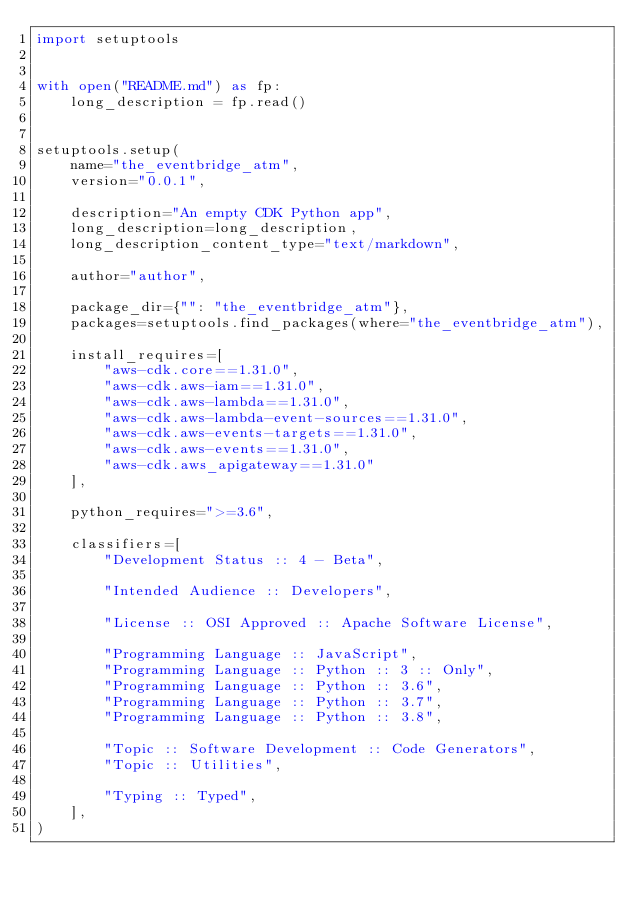Convert code to text. <code><loc_0><loc_0><loc_500><loc_500><_Python_>import setuptools


with open("README.md") as fp:
    long_description = fp.read()


setuptools.setup(
    name="the_eventbridge_atm",
    version="0.0.1",

    description="An empty CDK Python app",
    long_description=long_description,
    long_description_content_type="text/markdown",

    author="author",

    package_dir={"": "the_eventbridge_atm"},
    packages=setuptools.find_packages(where="the_eventbridge_atm"),

    install_requires=[
        "aws-cdk.core==1.31.0",
        "aws-cdk.aws-iam==1.31.0",
        "aws-cdk.aws-lambda==1.31.0",
        "aws-cdk.aws-lambda-event-sources==1.31.0",
        "aws-cdk.aws-events-targets==1.31.0",
        "aws-cdk.aws-events==1.31.0",
        "aws-cdk.aws_apigateway==1.31.0"
    ],

    python_requires=">=3.6",

    classifiers=[
        "Development Status :: 4 - Beta",

        "Intended Audience :: Developers",

        "License :: OSI Approved :: Apache Software License",

        "Programming Language :: JavaScript",
        "Programming Language :: Python :: 3 :: Only",
        "Programming Language :: Python :: 3.6",
        "Programming Language :: Python :: 3.7",
        "Programming Language :: Python :: 3.8",

        "Topic :: Software Development :: Code Generators",
        "Topic :: Utilities",

        "Typing :: Typed",
    ],
)
</code> 